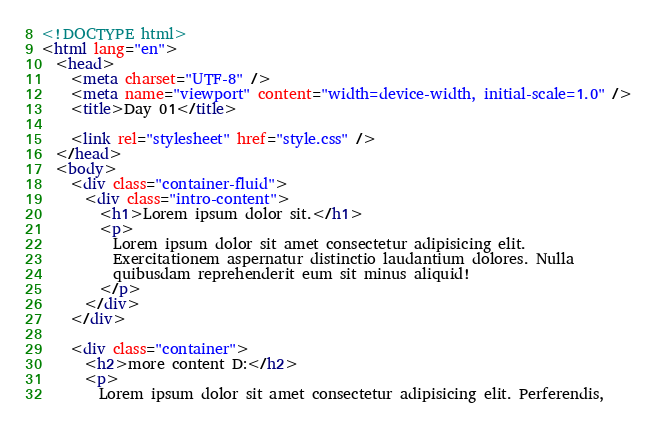Convert code to text. <code><loc_0><loc_0><loc_500><loc_500><_HTML_><!DOCTYPE html>
<html lang="en">
  <head>
    <meta charset="UTF-8" />
    <meta name="viewport" content="width=device-width, initial-scale=1.0" />
    <title>Day 01</title>

    <link rel="stylesheet" href="style.css" />
  </head>
  <body>
    <div class="container-fluid">
      <div class="intro-content">
        <h1>Lorem ipsum dolor sit.</h1>
        <p>
          Lorem ipsum dolor sit amet consectetur adipisicing elit.
          Exercitationem aspernatur distinctio laudantium dolores. Nulla
          quibusdam reprehenderit eum sit minus aliquid!
        </p>
      </div>
    </div>

    <div class="container">
      <h2>more content D:</h2>
      <p>
        Lorem ipsum dolor sit amet consectetur adipisicing elit. Perferendis,</code> 